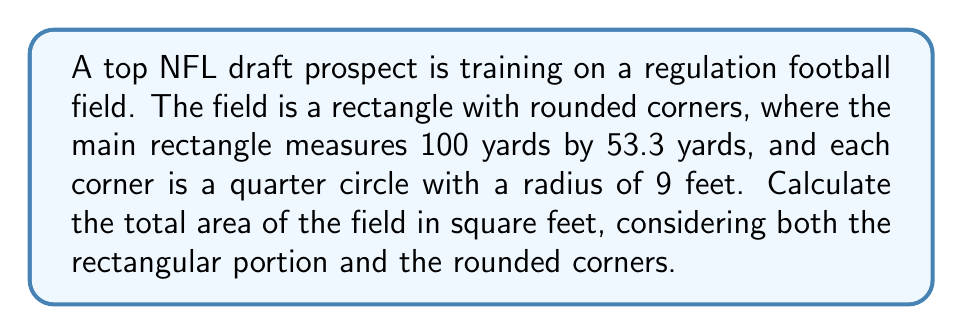Can you answer this question? Let's break this down step-by-step:

1) First, let's convert all measurements to feet:
   100 yards = 300 feet
   53.3 yards ≈ 160 feet (rounded)
   Radius of corners = 9 feet

2) Calculate the area of the main rectangle:
   $$A_{rectangle} = 300 \text{ ft} \times 160 \text{ ft} = 48,000 \text{ sq ft}$$

3) Calculate the area of a full circle with radius 9 feet:
   $$A_{circle} = \pi r^2 = \pi (9 \text{ ft})^2 \approx 254.47 \text{ sq ft}$$

4) Each corner is a quarter of this circle, so the area of one corner is:
   $$A_{corner} = \frac{1}{4} \times 254.47 \text{ sq ft} \approx 63.62 \text{ sq ft}$$

5) There are four corners, so the total area of the corners is:
   $$A_{total corners} = 4 \times 63.62 \text{ sq ft} \approx 254.47 \text{ sq ft}$$

6) The area these corners occupy is already included in our rectangle calculation, so we need to subtract it:
   $$A_{field} = A_{rectangle} - A_{total corners}$$
   $$A_{field} = 48,000 \text{ sq ft} - 254.47 \text{ sq ft} \approx 47,745.53 \text{ sq ft}$$

7) Finally, we add back the area of the rounded corners:
   $$A_{total} = A_{field} + A_{total corners}$$
   $$A_{total} = 47,745.53 \text{ sq ft} + 254.47 \text{ sq ft} = 48,000 \text{ sq ft}$$
Answer: 48,000 sq ft 